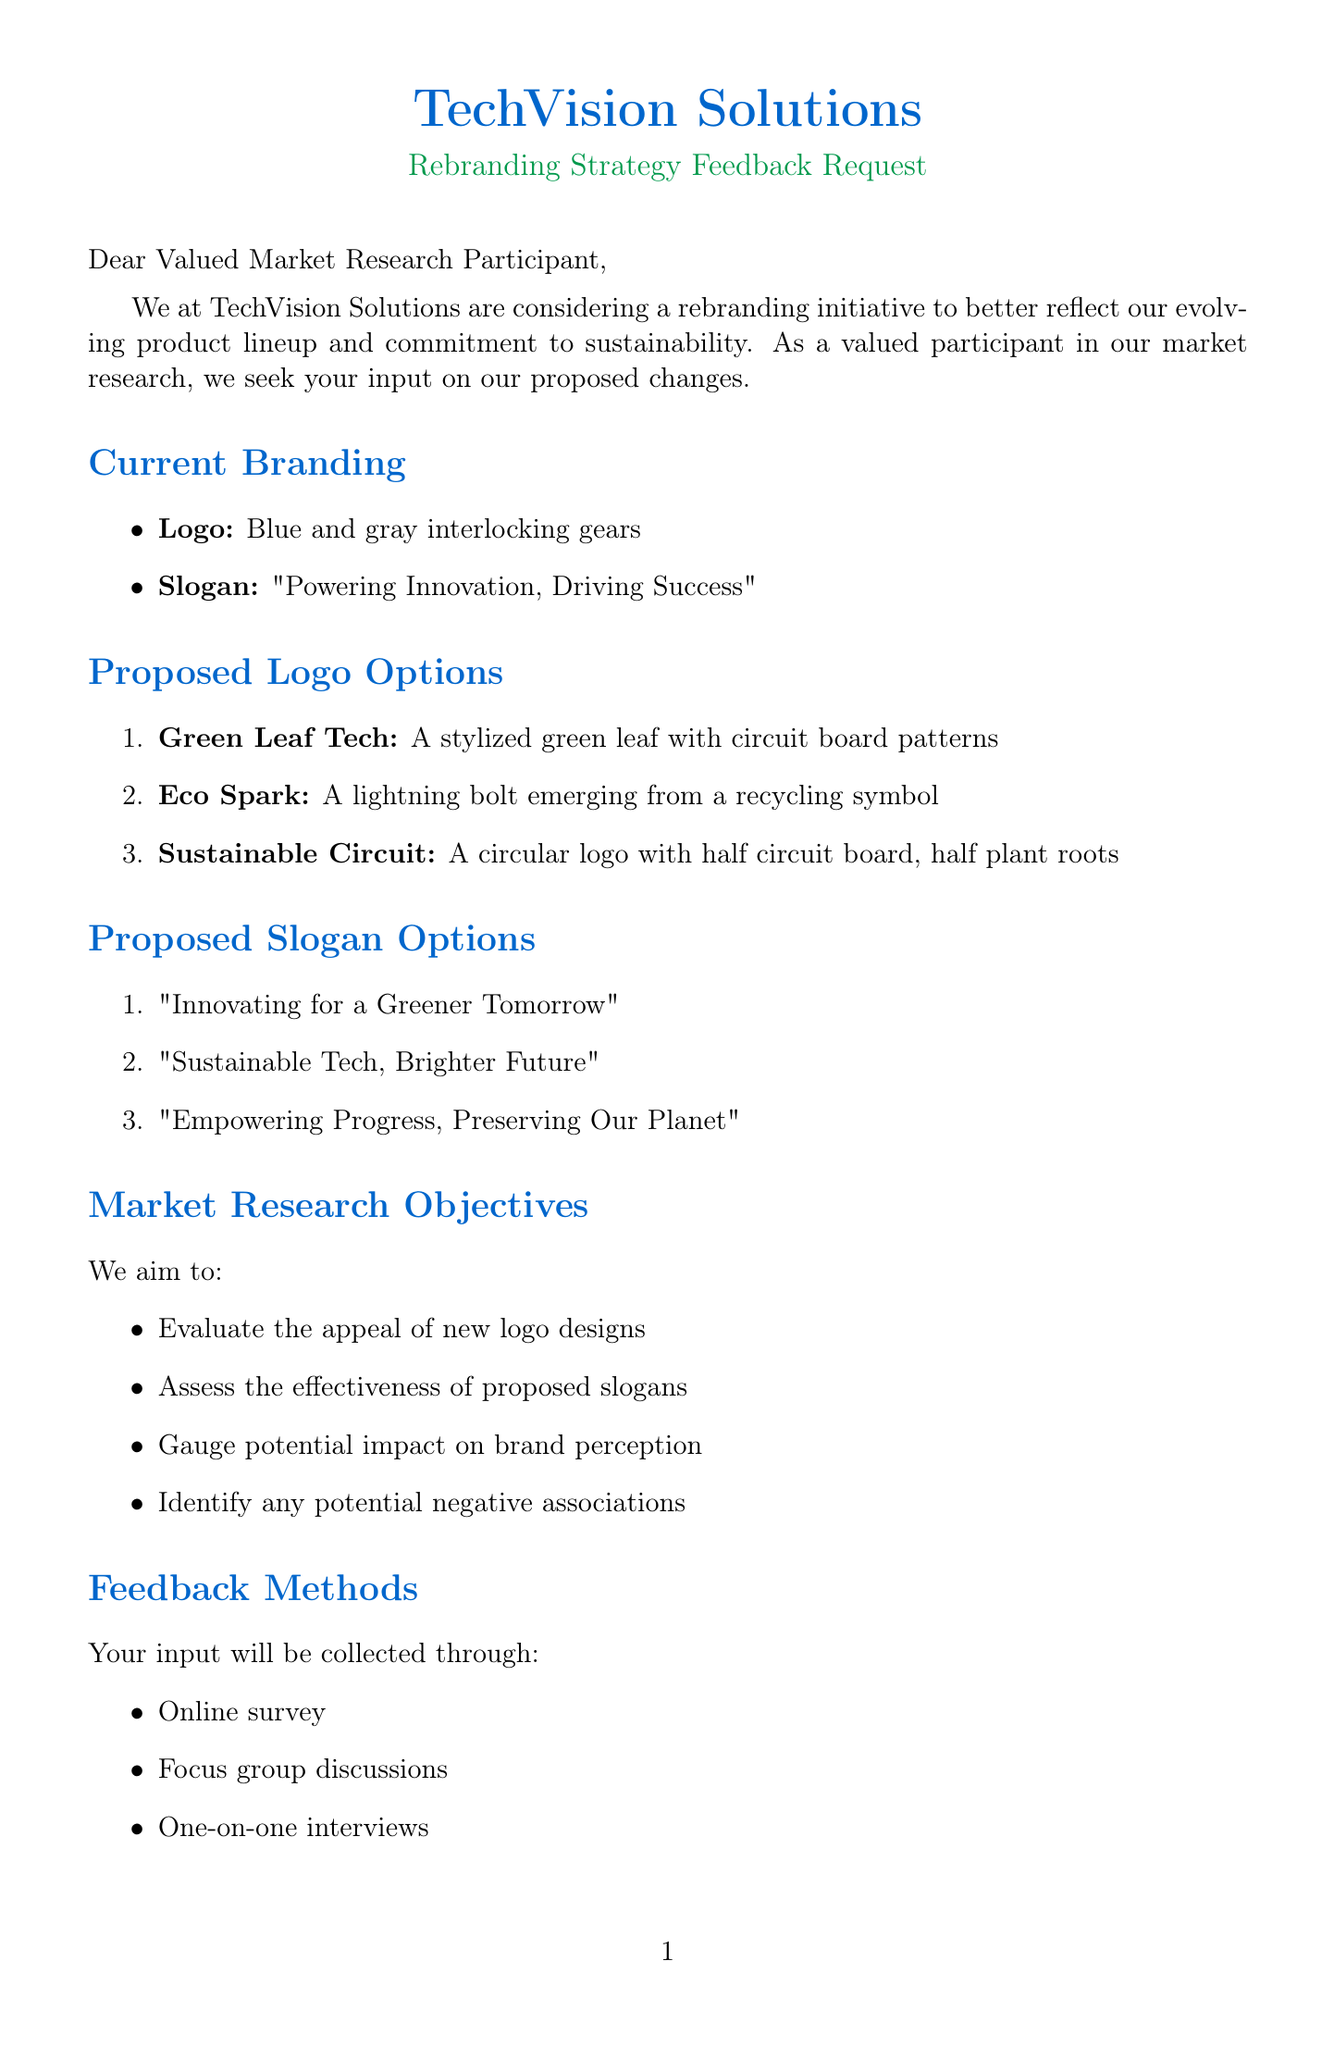What is the company name? The company name is mentioned at the beginning of the letter, identifying the organization requesting feedback.
Answer: TechVision Solutions What are the current logo colors? The current branding section specifies the colors used in the current logo.
Answer: Blue and gray What is the feedback deadline? The timeline section outlines the final date for providing feedback.
Answer: August 15, 2023 Who is the Marketing Director? The contact information section provides the name and title of the person responsible for the letter.
Answer: Sarah Johnson What is one proposed slogan option? The proposed slogans are listed, and any one of them can be cited as an example.
Answer: Innovating for a Greener Tomorrow How many proposed logo options are there? The section about proposed logo options indicates the total number presented for evaluation.
Answer: Three What incentive is offered to focus group participants? The incentives section specifies the reward for individuals participating in focus group discussions.
Answer: $100 cash and product samples What is the reason for the rebranding? The reason for the rebranding is provided in the introduction, focusing on the company's evolving focus.
Answer: To better reflect our evolving product lineup and commitment to sustainability What are the feedback methods mentioned? The feedback methods section lists the ways in which participants can provide their input.
Answer: Online survey, Focus group discussions, One-on-one interviews 